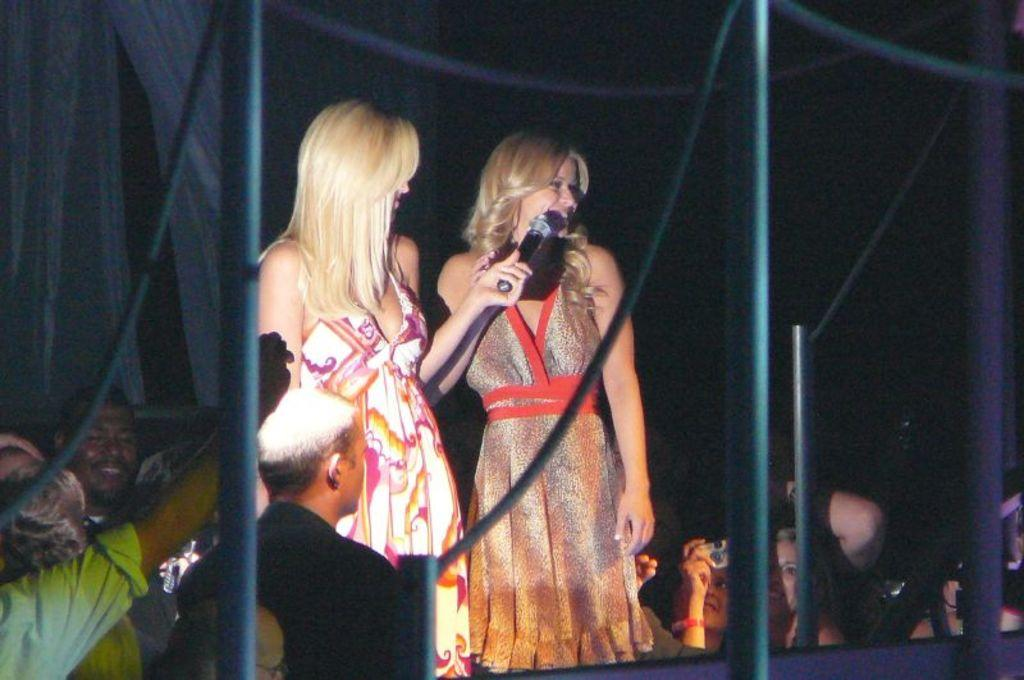What is happening in the image? The image appears to depict an event. Who is on the stage during this event? There are two women standing on a stage. What is the audience like at this event? There is a crowd around the stage. What can be seen in front of the women on the stage? There are iron rods in front of the women on the stage. Can you see the brother of one of the women on the stage in the image? There is no mention of a brother or any other family members in the image, so we cannot determine if the brother is present. 